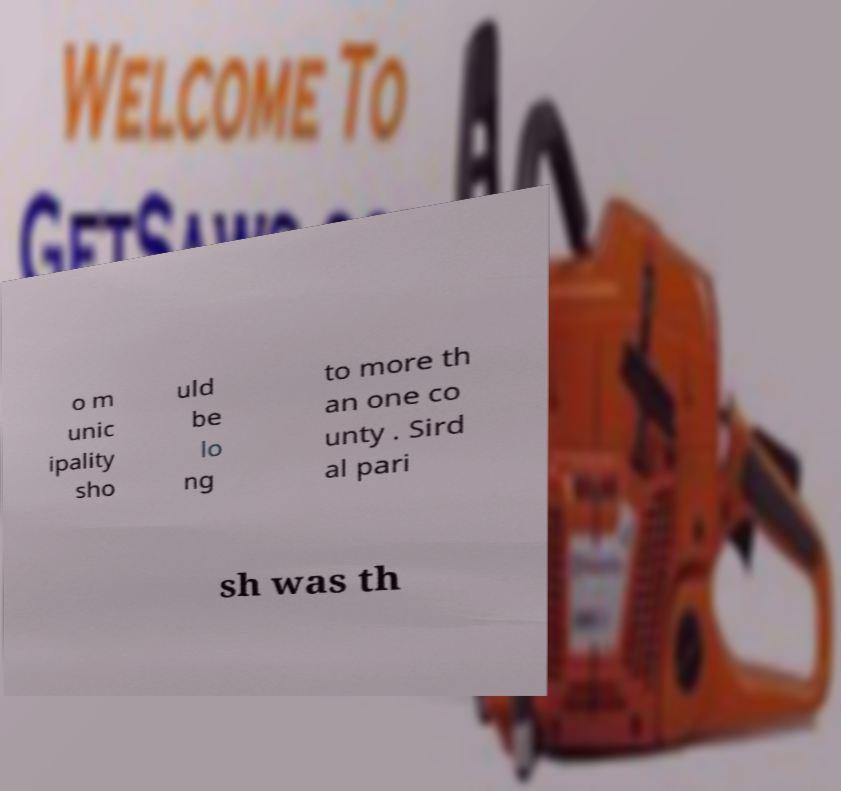Please identify and transcribe the text found in this image. o m unic ipality sho uld be lo ng to more th an one co unty . Sird al pari sh was th 